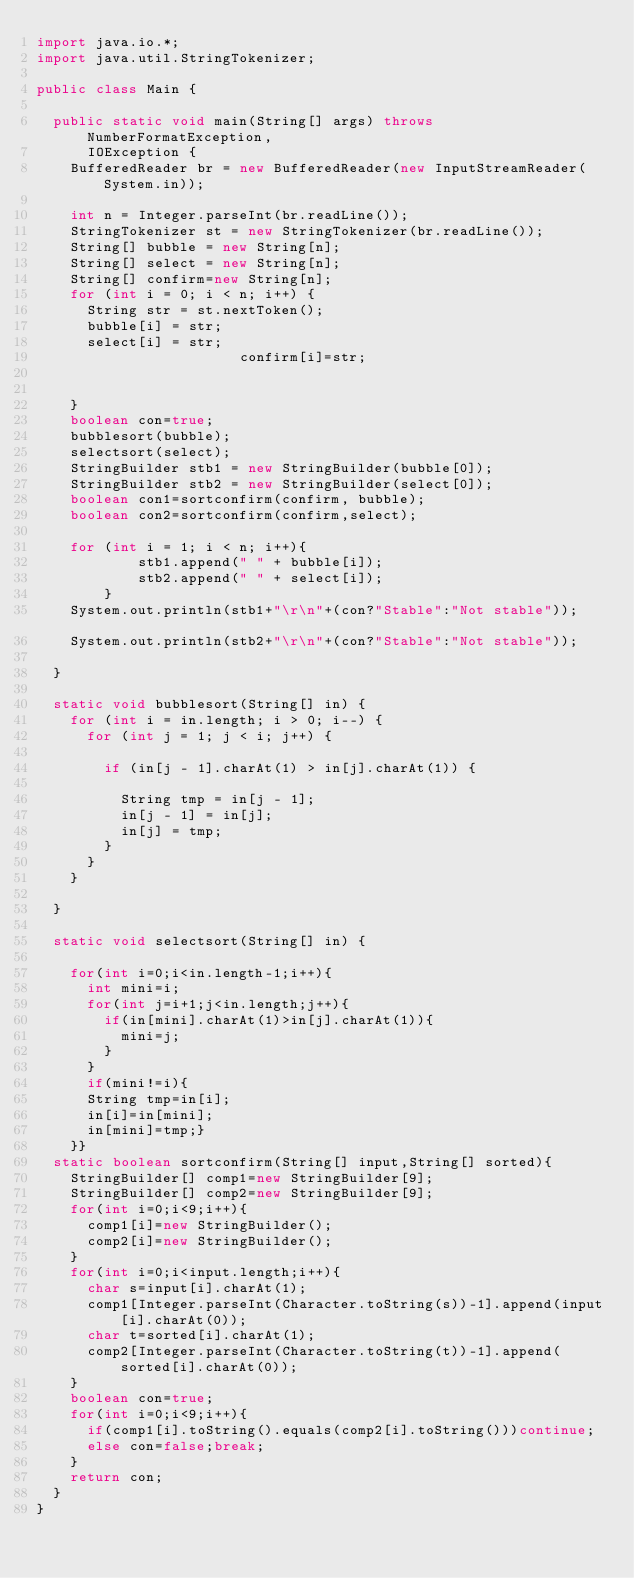Convert code to text. <code><loc_0><loc_0><loc_500><loc_500><_Java_>import java.io.*;
import java.util.StringTokenizer;

public class Main {

	public static void main(String[] args) throws NumberFormatException,
			IOException {
		BufferedReader br = new BufferedReader(new InputStreamReader(System.in));
		
		int n = Integer.parseInt(br.readLine());
		StringTokenizer st = new StringTokenizer(br.readLine());
		String[] bubble = new String[n];
		String[] select = new String[n];
		String[] confirm=new String[n];
		for (int i = 0; i < n; i++) {
			String str = st.nextToken();
			bubble[i] = str;
			select[i] = str;
                        confirm[i]=str;
			
			
		}
		boolean con=true;
		bubblesort(bubble);
		selectsort(select);
		StringBuilder stb1 = new StringBuilder(bubble[0]);
		StringBuilder stb2 = new StringBuilder(select[0]);
		boolean con1=sortconfirm(confirm, bubble);
		boolean con2=sortconfirm(confirm,select);
		
		for (int i = 1; i < n; i++){
            stb1.append(" " + bubble[i]);
            stb2.append(" " + select[i]);
        }
		System.out.println(stb1+"\r\n"+(con?"Stable":"Not stable"));			
		System.out.println(stb2+"\r\n"+(con?"Stable":"Not stable"));

	}

	static void bubblesort(String[] in) {
		for (int i = in.length; i > 0; i--) {
			for (int j = 1; j < i; j++) {

				if (in[j - 1].charAt(1) > in[j].charAt(1)) {
					
					String tmp = in[j - 1];
					in[j - 1] = in[j];
					in[j] = tmp;
				}
			}
		}
		
	}

	static void selectsort(String[] in) {
		
		for(int i=0;i<in.length-1;i++){
			int mini=i;
			for(int j=i+1;j<in.length;j++){
				if(in[mini].charAt(1)>in[j].charAt(1)){
					mini=j;
				}
			}
			if(mini!=i){
			String tmp=in[i];
			in[i]=in[mini];
			in[mini]=tmp;}
		}}
	static boolean sortconfirm(String[] input,String[] sorted){
		StringBuilder[] comp1=new StringBuilder[9];
		StringBuilder[] comp2=new StringBuilder[9];
		for(int i=0;i<9;i++){
			comp1[i]=new StringBuilder();
			comp2[i]=new StringBuilder();
		}
		for(int i=0;i<input.length;i++){
			char s=input[i].charAt(1);
			comp1[Integer.parseInt(Character.toString(s))-1].append(input[i].charAt(0));
			char t=sorted[i].charAt(1);
			comp2[Integer.parseInt(Character.toString(t))-1].append(sorted[i].charAt(0));
		}
		boolean con=true;
		for(int i=0;i<9;i++){
			if(comp1[i].toString().equals(comp2[i].toString()))continue;
			else con=false;break;
		}
		return con;
	}
}</code> 